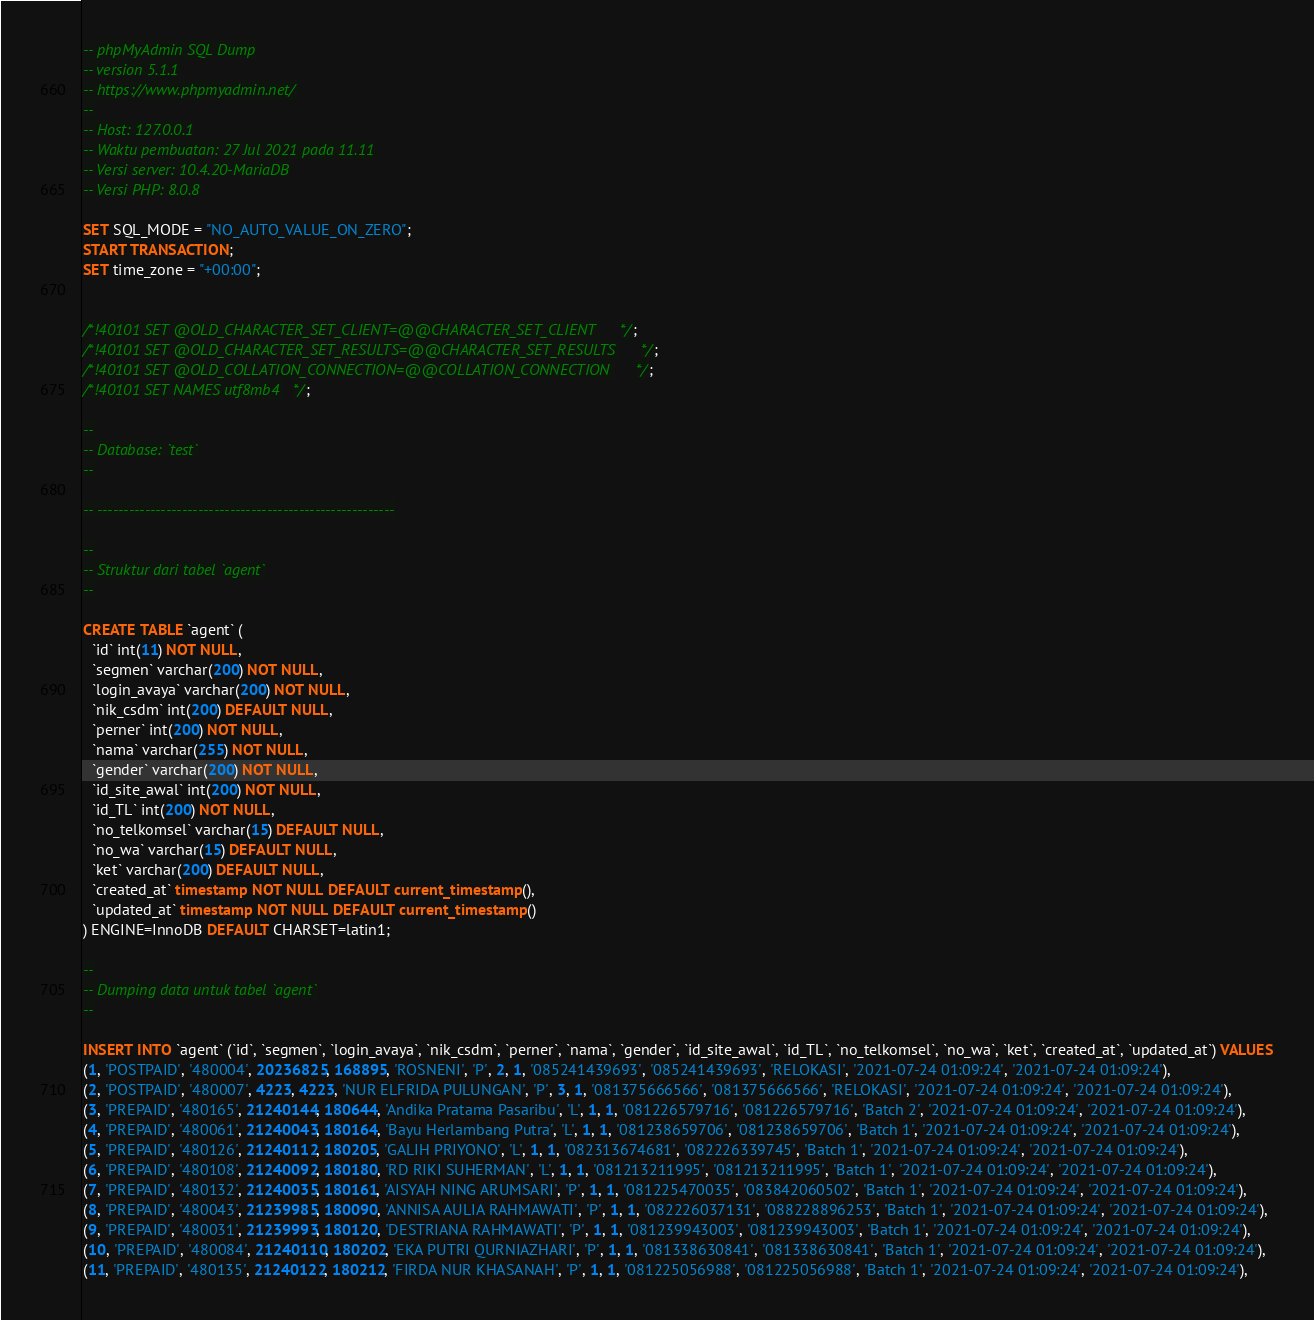<code> <loc_0><loc_0><loc_500><loc_500><_SQL_>-- phpMyAdmin SQL Dump
-- version 5.1.1
-- https://www.phpmyadmin.net/
--
-- Host: 127.0.0.1
-- Waktu pembuatan: 27 Jul 2021 pada 11.11
-- Versi server: 10.4.20-MariaDB
-- Versi PHP: 8.0.8

SET SQL_MODE = "NO_AUTO_VALUE_ON_ZERO";
START TRANSACTION;
SET time_zone = "+00:00";


/*!40101 SET @OLD_CHARACTER_SET_CLIENT=@@CHARACTER_SET_CLIENT */;
/*!40101 SET @OLD_CHARACTER_SET_RESULTS=@@CHARACTER_SET_RESULTS */;
/*!40101 SET @OLD_COLLATION_CONNECTION=@@COLLATION_CONNECTION */;
/*!40101 SET NAMES utf8mb4 */;

--
-- Database: `test`
--

-- --------------------------------------------------------

--
-- Struktur dari tabel `agent`
--

CREATE TABLE `agent` (
  `id` int(11) NOT NULL,
  `segmen` varchar(200) NOT NULL,
  `login_avaya` varchar(200) NOT NULL,
  `nik_csdm` int(200) DEFAULT NULL,
  `perner` int(200) NOT NULL,
  `nama` varchar(255) NOT NULL,
  `gender` varchar(200) NOT NULL,
  `id_site_awal` int(200) NOT NULL,
  `id_TL` int(200) NOT NULL,
  `no_telkomsel` varchar(15) DEFAULT NULL,
  `no_wa` varchar(15) DEFAULT NULL,
  `ket` varchar(200) DEFAULT NULL,
  `created_at` timestamp NOT NULL DEFAULT current_timestamp(),
  `updated_at` timestamp NOT NULL DEFAULT current_timestamp()
) ENGINE=InnoDB DEFAULT CHARSET=latin1;

--
-- Dumping data untuk tabel `agent`
--

INSERT INTO `agent` (`id`, `segmen`, `login_avaya`, `nik_csdm`, `perner`, `nama`, `gender`, `id_site_awal`, `id_TL`, `no_telkomsel`, `no_wa`, `ket`, `created_at`, `updated_at`) VALUES
(1, 'POSTPAID', '480004', 20236825, 168895, 'ROSNENI', 'P', 2, 1, '085241439693', '085241439693', 'RELOKASI', '2021-07-24 01:09:24', '2021-07-24 01:09:24'),
(2, 'POSTPAID', '480007', 4223, 4223, 'NUR ELFRIDA PULUNGAN', 'P', 3, 1, '081375666566', '081375666566', 'RELOKASI', '2021-07-24 01:09:24', '2021-07-24 01:09:24'),
(3, 'PREPAID', '480165', 21240144, 180644, 'Andika Pratama Pasaribu', 'L', 1, 1, '081226579716', '081226579716', 'Batch 2', '2021-07-24 01:09:24', '2021-07-24 01:09:24'),
(4, 'PREPAID', '480061', 21240043, 180164, 'Bayu Herlambang Putra', 'L', 1, 1, '081238659706', '081238659706', 'Batch 1', '2021-07-24 01:09:24', '2021-07-24 01:09:24'),
(5, 'PREPAID', '480126', 21240112, 180205, 'GALIH PRIYONO', 'L', 1, 1, '082313674681', '082226339745', 'Batch 1', '2021-07-24 01:09:24', '2021-07-24 01:09:24'),
(6, 'PREPAID', '480108', 21240092, 180180, 'RD RIKI SUHERMAN', 'L', 1, 1, '081213211995', '081213211995', 'Batch 1', '2021-07-24 01:09:24', '2021-07-24 01:09:24'),
(7, 'PREPAID', '480132', 21240035, 180161, 'AISYAH NING ARUMSARI', 'P', 1, 1, '081225470035', '083842060502', 'Batch 1', '2021-07-24 01:09:24', '2021-07-24 01:09:24'),
(8, 'PREPAID', '480043', 21239985, 180090, 'ANNISA AULIA RAHMAWATI', 'P', 1, 1, '082226037131', '088228896253', 'Batch 1', '2021-07-24 01:09:24', '2021-07-24 01:09:24'),
(9, 'PREPAID', '480031', 21239993, 180120, 'DESTRIANA RAHMAWATI', 'P', 1, 1, '081239943003', '081239943003', 'Batch 1', '2021-07-24 01:09:24', '2021-07-24 01:09:24'),
(10, 'PREPAID', '480084', 21240110, 180202, 'EKA PUTRI QURNIAZHARI', 'P', 1, 1, '081338630841', '081338630841', 'Batch 1', '2021-07-24 01:09:24', '2021-07-24 01:09:24'),
(11, 'PREPAID', '480135', 21240122, 180212, 'FIRDA NUR KHASANAH', 'P', 1, 1, '081225056988', '081225056988', 'Batch 1', '2021-07-24 01:09:24', '2021-07-24 01:09:24'),</code> 